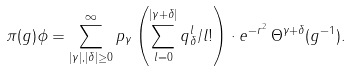Convert formula to latex. <formula><loc_0><loc_0><loc_500><loc_500>\pi ( g ) \phi = \sum _ { | \gamma | , | \delta | \geq 0 } ^ { \infty } p _ { \gamma } \left ( \sum _ { l = 0 } ^ { | \gamma + \delta | } q _ { \delta } ^ { l } / l ! \right ) \cdot e ^ { - r ^ { 2 } } \, \Theta ^ { \gamma + \delta } ( g ^ { - 1 } ) .</formula> 